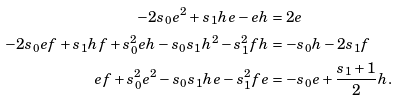Convert formula to latex. <formula><loc_0><loc_0><loc_500><loc_500>- 2 s _ { 0 } e ^ { 2 } + s _ { 1 } h e - e h & = 2 e \\ - 2 s _ { 0 } e f + s _ { 1 } h f + s _ { 0 } ^ { 2 } e h - s _ { 0 } s _ { 1 } h ^ { 2 } - s _ { 1 } ^ { 2 } f h & = - s _ { 0 } h - 2 s _ { 1 } f \\ e f + s _ { 0 } ^ { 2 } e ^ { 2 } - s _ { 0 } s _ { 1 } h e - s _ { 1 } ^ { 2 } f e & = - s _ { 0 } e + \frac { s _ { 1 } + 1 } { 2 } h .</formula> 